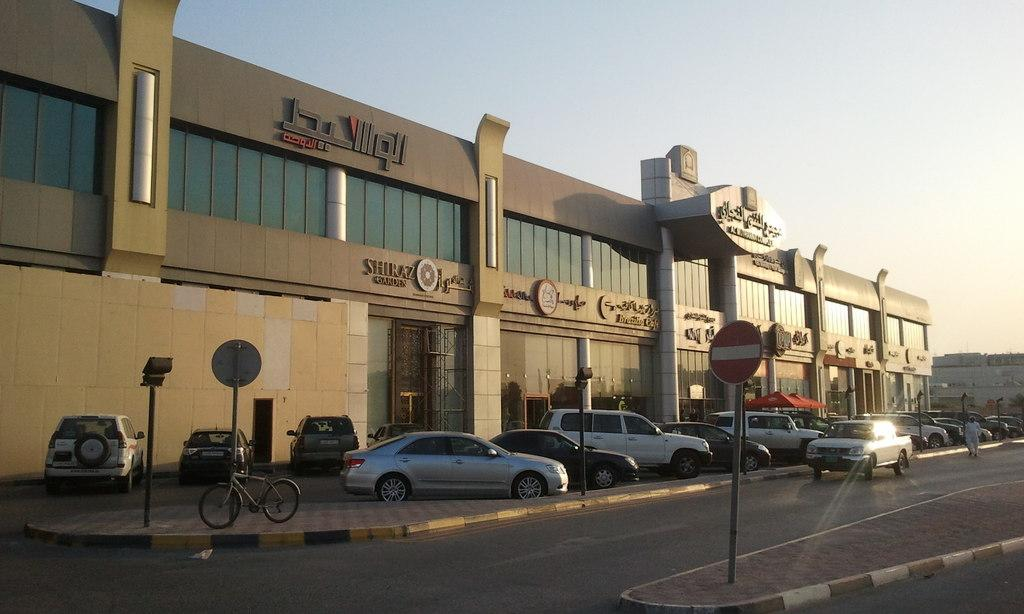What type of establishment is shown in the image? There is a store in the image. What can be seen in the parking area near the store? There are vehicles parked in the image. What is happening on the road in the image? A car is moving on the road, and a person is walking on the road in the image. What is the color of the sky in the image? The sky is blue in the image. What type of canvas is being used to paint the store in the image? There is no canvas or painting present in the image; it is a photograph of a store. What type of plough is being used to till the road in the image? There is no plough present in the image; the road is being used by vehicles and pedestrians. What type of kettle is being used to boil water in the image? There is no kettle present in the image; the focus is on the store, vehicles, and people. 